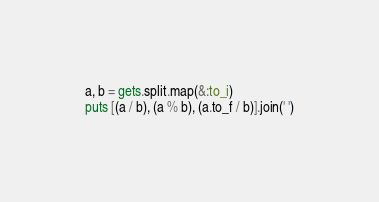Convert code to text. <code><loc_0><loc_0><loc_500><loc_500><_Ruby_>a, b = gets.split.map(&:to_i)
puts [(a / b), (a % b), (a.to_f / b)].join(' ')</code> 